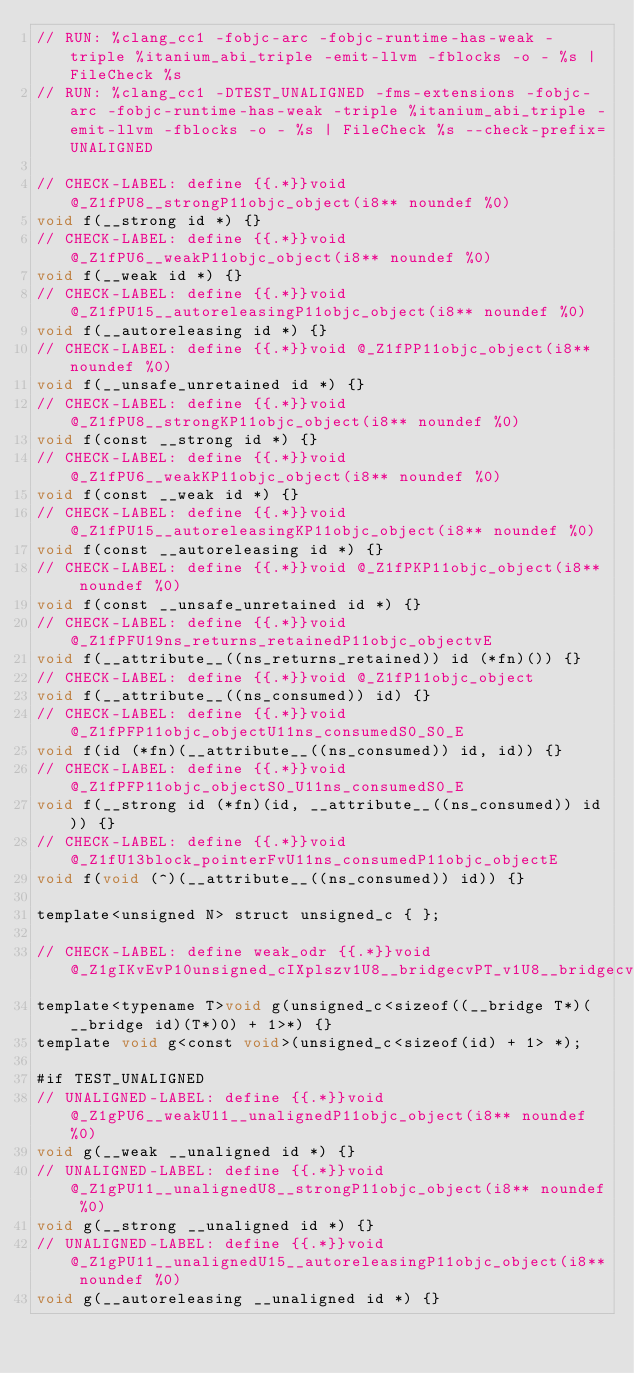Convert code to text. <code><loc_0><loc_0><loc_500><loc_500><_ObjectiveC_>// RUN: %clang_cc1 -fobjc-arc -fobjc-runtime-has-weak -triple %itanium_abi_triple -emit-llvm -fblocks -o - %s | FileCheck %s
// RUN: %clang_cc1 -DTEST_UNALIGNED -fms-extensions -fobjc-arc -fobjc-runtime-has-weak -triple %itanium_abi_triple -emit-llvm -fblocks -o - %s | FileCheck %s --check-prefix=UNALIGNED

// CHECK-LABEL: define {{.*}}void @_Z1fPU8__strongP11objc_object(i8** noundef %0)
void f(__strong id *) {}
// CHECK-LABEL: define {{.*}}void @_Z1fPU6__weakP11objc_object(i8** noundef %0)
void f(__weak id *) {}
// CHECK-LABEL: define {{.*}}void @_Z1fPU15__autoreleasingP11objc_object(i8** noundef %0)
void f(__autoreleasing id *) {}
// CHECK-LABEL: define {{.*}}void @_Z1fPP11objc_object(i8** noundef %0)
void f(__unsafe_unretained id *) {}
// CHECK-LABEL: define {{.*}}void @_Z1fPU8__strongKP11objc_object(i8** noundef %0)
void f(const __strong id *) {}
// CHECK-LABEL: define {{.*}}void @_Z1fPU6__weakKP11objc_object(i8** noundef %0)
void f(const __weak id *) {}
// CHECK-LABEL: define {{.*}}void @_Z1fPU15__autoreleasingKP11objc_object(i8** noundef %0)
void f(const __autoreleasing id *) {}
// CHECK-LABEL: define {{.*}}void @_Z1fPKP11objc_object(i8** noundef %0)
void f(const __unsafe_unretained id *) {}
// CHECK-LABEL: define {{.*}}void @_Z1fPFU19ns_returns_retainedP11objc_objectvE
void f(__attribute__((ns_returns_retained)) id (*fn)()) {}
// CHECK-LABEL: define {{.*}}void @_Z1fP11objc_object
void f(__attribute__((ns_consumed)) id) {}
// CHECK-LABEL: define {{.*}}void @_Z1fPFP11objc_objectU11ns_consumedS0_S0_E
void f(id (*fn)(__attribute__((ns_consumed)) id, id)) {}
// CHECK-LABEL: define {{.*}}void @_Z1fPFP11objc_objectS0_U11ns_consumedS0_E
void f(__strong id (*fn)(id, __attribute__((ns_consumed)) id)) {}
// CHECK-LABEL: define {{.*}}void @_Z1fU13block_pointerFvU11ns_consumedP11objc_objectE
void f(void (^)(__attribute__((ns_consumed)) id)) {}

template<unsigned N> struct unsigned_c { };

// CHECK-LABEL: define weak_odr {{.*}}void @_Z1gIKvEvP10unsigned_cIXplszv1U8__bridgecvPT_v1U8__bridgecvP11objc_objectcvS3_Li0ELi1EEE
template<typename T>void g(unsigned_c<sizeof((__bridge T*)(__bridge id)(T*)0) + 1>*) {}
template void g<const void>(unsigned_c<sizeof(id) + 1> *);

#if TEST_UNALIGNED
// UNALIGNED-LABEL: define {{.*}}void @_Z1gPU6__weakU11__unalignedP11objc_object(i8** noundef %0)
void g(__weak __unaligned id *) {}
// UNALIGNED-LABEL: define {{.*}}void @_Z1gPU11__unalignedU8__strongP11objc_object(i8** noundef %0)
void g(__strong __unaligned id *) {}
// UNALIGNED-LABEL: define {{.*}}void @_Z1gPU11__unalignedU15__autoreleasingP11objc_object(i8** noundef %0)
void g(__autoreleasing __unaligned id *) {}</code> 